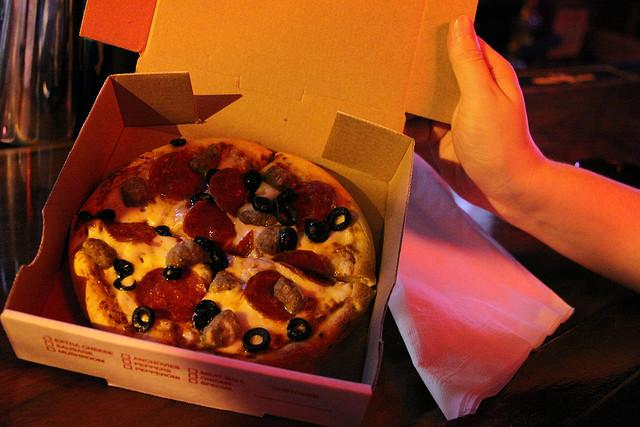What type person would enjoy this pizza? single 